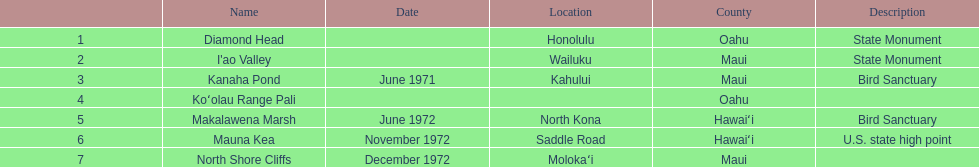What is the title of the unique landmark that also serves as a u.s. state high point? Mauna Kea. 